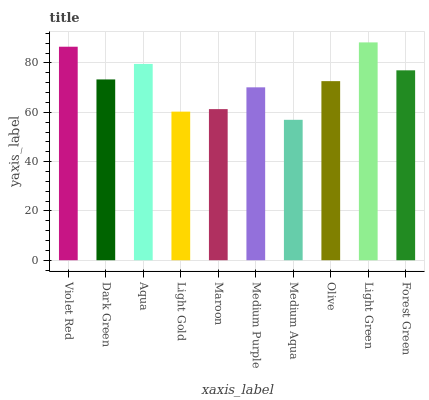Is Medium Aqua the minimum?
Answer yes or no. Yes. Is Light Green the maximum?
Answer yes or no. Yes. Is Dark Green the minimum?
Answer yes or no. No. Is Dark Green the maximum?
Answer yes or no. No. Is Violet Red greater than Dark Green?
Answer yes or no. Yes. Is Dark Green less than Violet Red?
Answer yes or no. Yes. Is Dark Green greater than Violet Red?
Answer yes or no. No. Is Violet Red less than Dark Green?
Answer yes or no. No. Is Dark Green the high median?
Answer yes or no. Yes. Is Olive the low median?
Answer yes or no. Yes. Is Medium Aqua the high median?
Answer yes or no. No. Is Light Gold the low median?
Answer yes or no. No. 